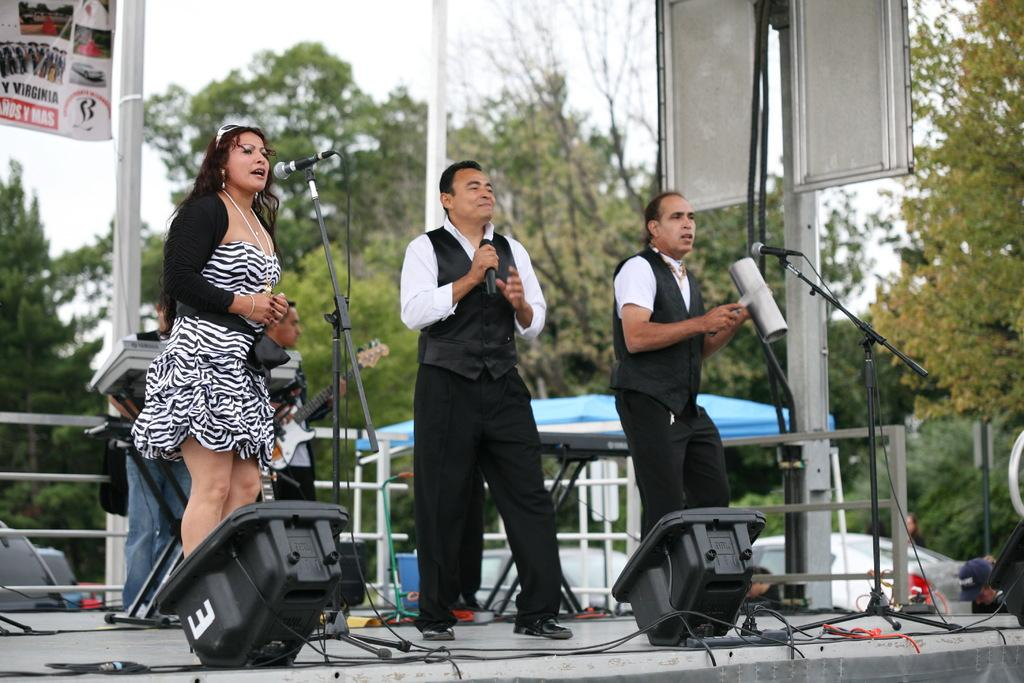What are the people in the image doing? The people are standing on stage in the image. What can be seen connected to the stage? There are wires visible in the image. What musical instrument is present in the image? A guitar is present in the image. What is hanging above the stage? There is a banner in the image. What type of natural environment is visible in the image? Trees are visible in the image. What structures are present in the image? Poles are present in the image. What type of shelter is visible in the image? There is a tent in the image. What is visible in the background of the image? The sky is visible in the background of the image. Can you tell me how many boxes are stacked next to the tent in the image? There is no box present in the image; only a tent, trees, poles, a banner, a guitar, wires, and people on stage are visible. What type of relation do the people on stage have with the snail in the image? There is no snail present in the image, so it is not possible to determine any relation between the people on stage and a snail. 